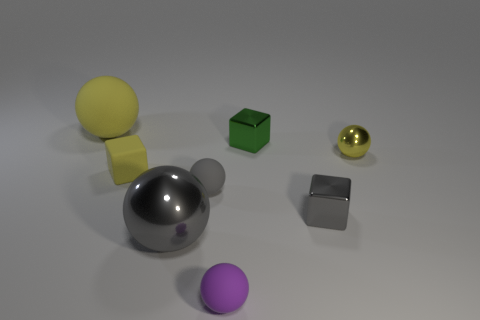Subtract all purple balls. Subtract all brown cylinders. How many balls are left? 4 Add 1 green cubes. How many objects exist? 9 Subtract all blocks. How many objects are left? 5 Subtract 0 red cylinders. How many objects are left? 8 Subtract all blocks. Subtract all small purple spheres. How many objects are left? 4 Add 2 small yellow balls. How many small yellow balls are left? 3 Add 1 gray things. How many gray things exist? 4 